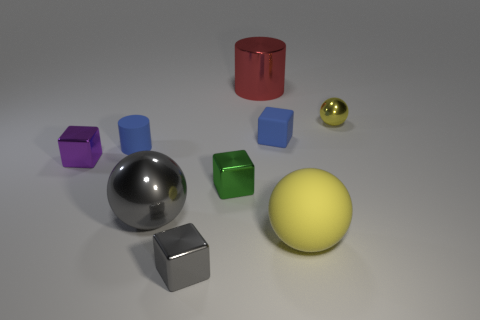How many small things are behind the small matte block behind the purple object?
Your response must be concise. 1. Are there any blue matte things of the same shape as the small green metal object?
Make the answer very short. Yes. Do the big thing that is behind the small purple block and the tiny blue matte object in front of the blue block have the same shape?
Offer a terse response. Yes. What number of objects are either yellow metal objects or gray metal objects?
Keep it short and to the point. 3. There is a green shiny object that is the same shape as the tiny purple metallic thing; what is its size?
Your answer should be very brief. Small. Are there more tiny shiny things that are on the left side of the large red cylinder than tiny red metallic balls?
Offer a very short reply. Yes. Do the small yellow thing and the large yellow sphere have the same material?
Ensure brevity in your answer.  No. What number of objects are tiny rubber objects that are left of the big red thing or yellow things that are in front of the blue cylinder?
Provide a short and direct response. 2. The other matte thing that is the same shape as the small gray object is what color?
Ensure brevity in your answer.  Blue. How many rubber objects are the same color as the tiny cylinder?
Your response must be concise. 1. 